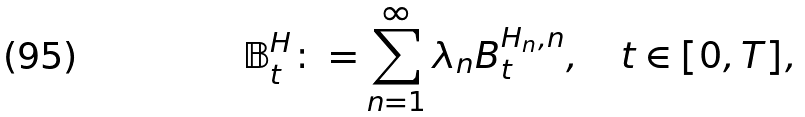<formula> <loc_0><loc_0><loc_500><loc_500>\mathbb { B } _ { t } ^ { H } \colon = \sum _ { n = 1 } ^ { \infty } \lambda _ { n } B _ { t } ^ { H _ { n } , n } , \quad t \in [ 0 , T ] ,</formula> 